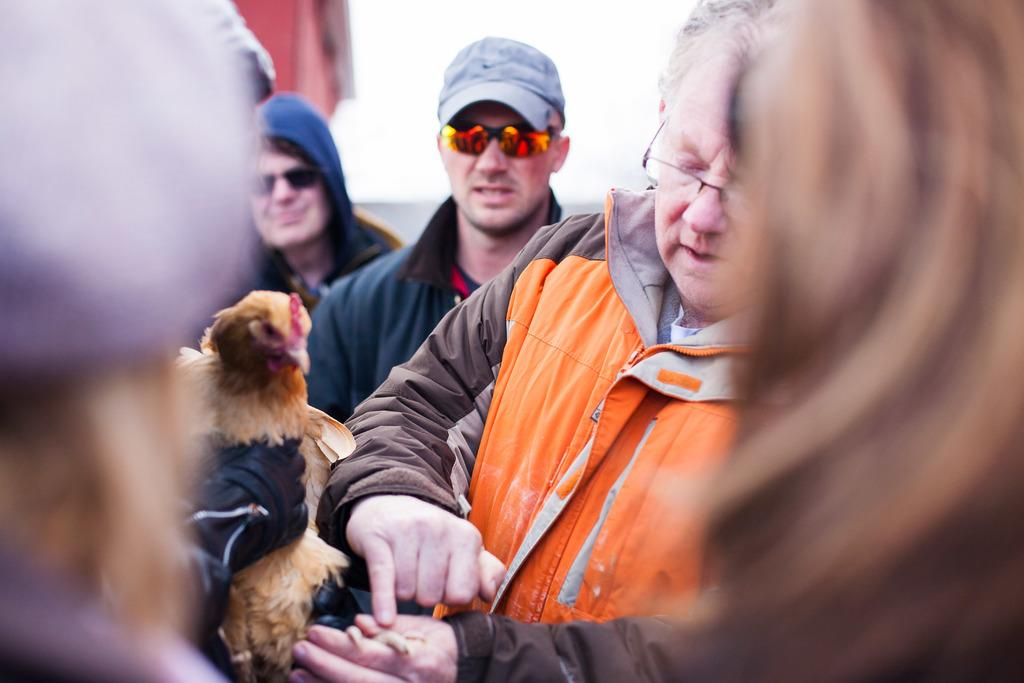What is the man on the left side of the image wearing? The man on the left side of the image is wearing an orange jacket. What is the man on the right side of the image wearing? The man on the right side of the image is wearing a blue jacket, grey cap, and goggles. How many people are present in the image? People are present on both the left and right sides of the image, so there are at least two people in the image. What type of land can be seen in the background of the image? There is no land visible in the background of the image; it is not mentioned in the provided facts. How many sisters are present in the image? There is no mention of sisters in the image, so it cannot be determined from the provided facts. 